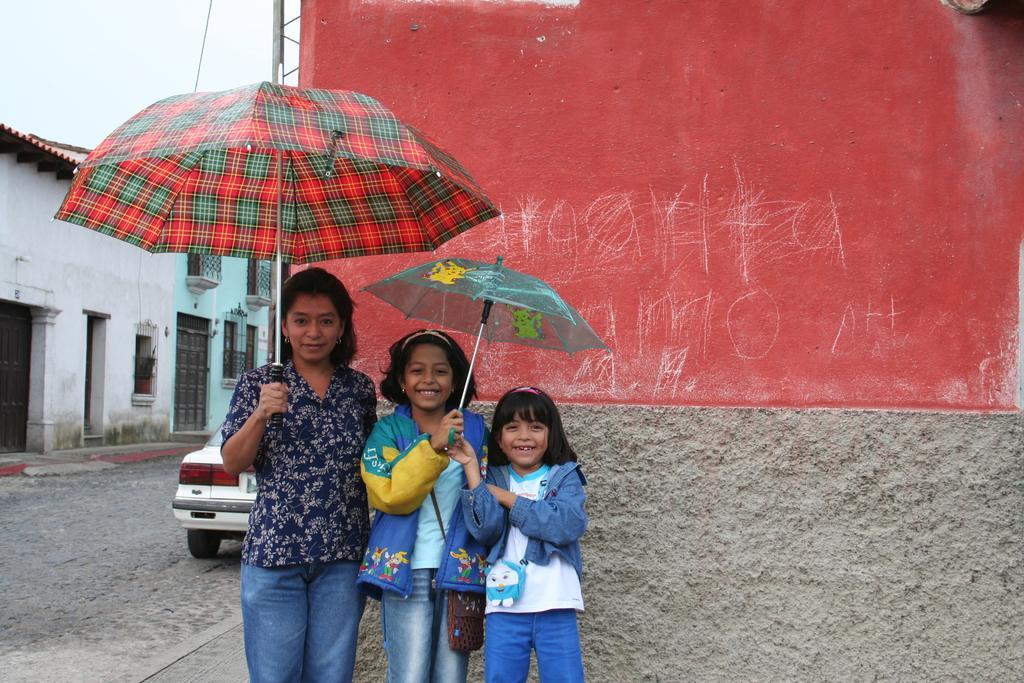Can you describe this image briefly? In this image we can see a few people standing and holding an umbrella and there is a wall in the background. We can see two houses on the left side and there is a car on the road. 